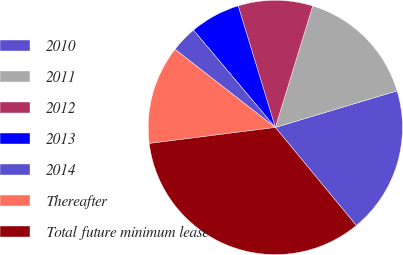<chart> <loc_0><loc_0><loc_500><loc_500><pie_chart><fcel>2010<fcel>2011<fcel>2012<fcel>2013<fcel>2014<fcel>Thereafter<fcel>Total future minimum lease<nl><fcel>18.66%<fcel>15.6%<fcel>9.47%<fcel>6.41%<fcel>3.34%<fcel>12.54%<fcel>33.98%<nl></chart> 